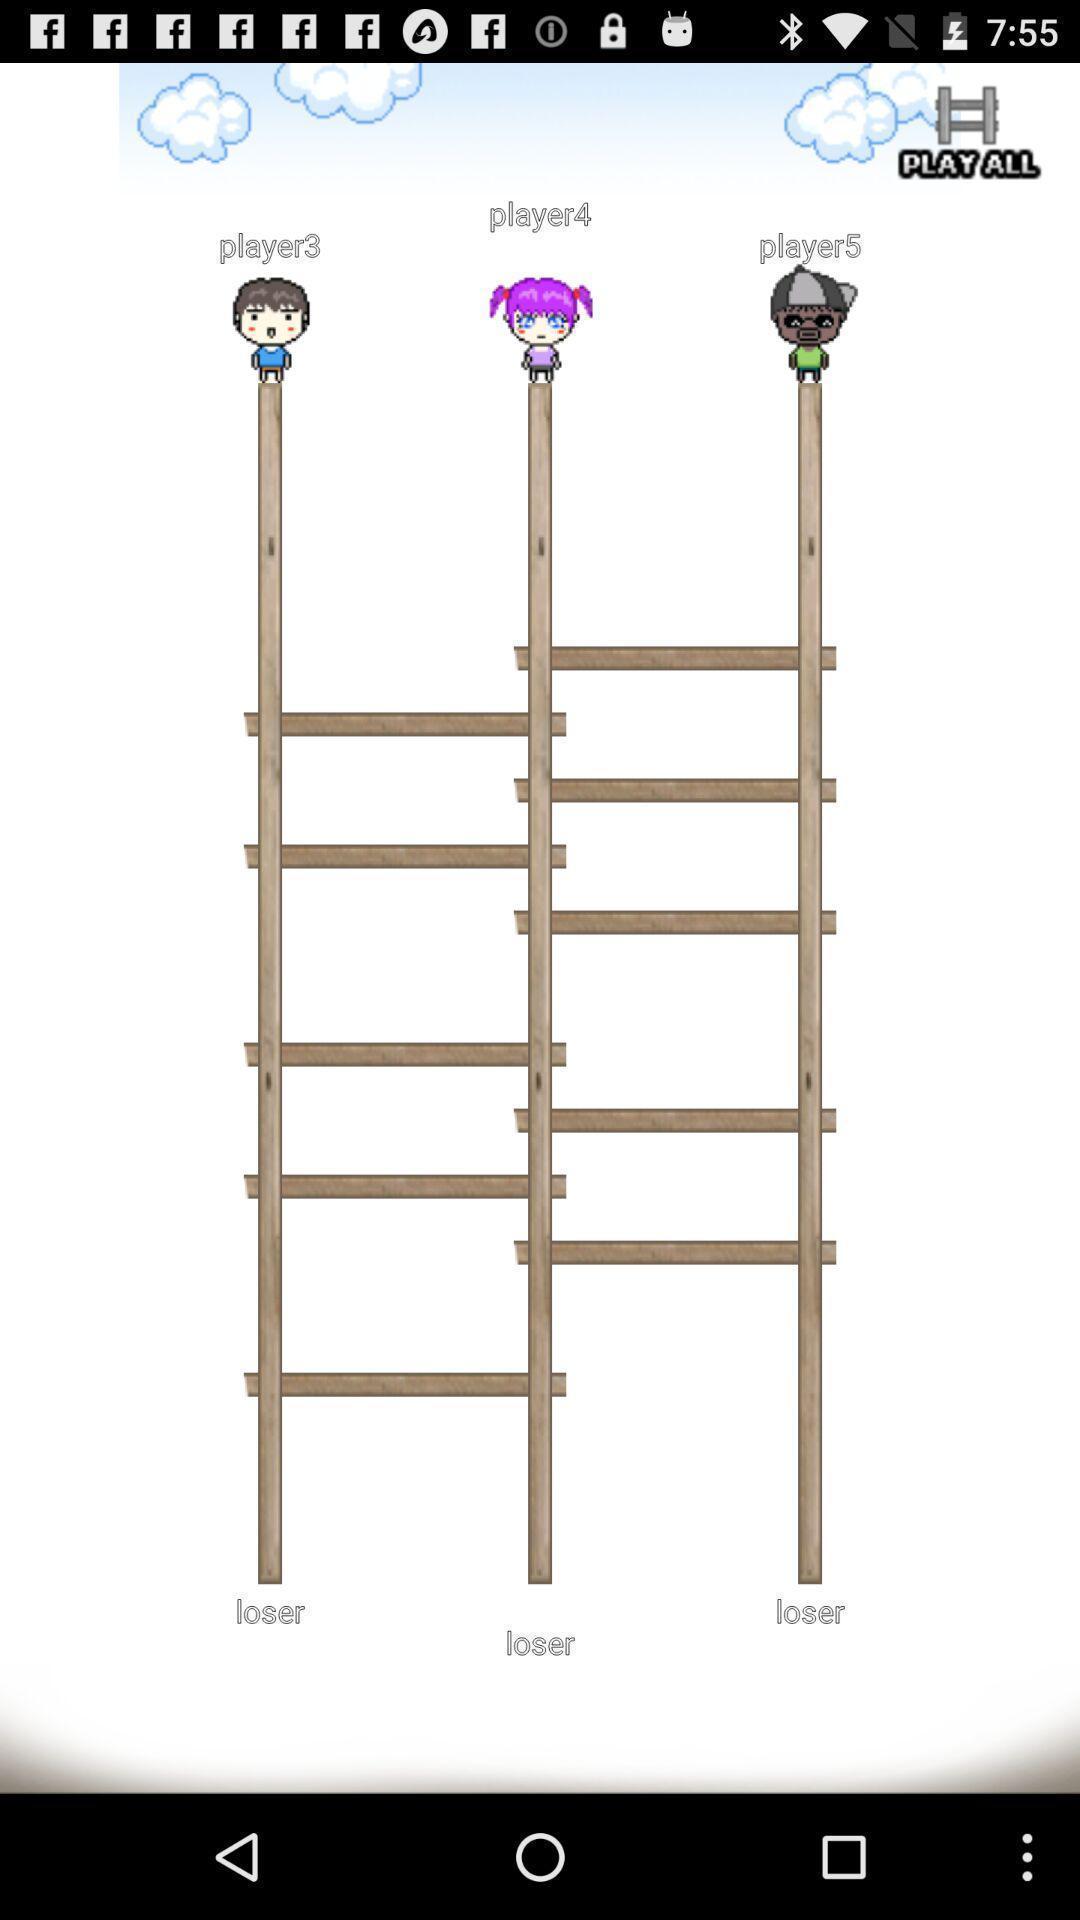Give me a narrative description of this picture. Screen page displaying players status. 